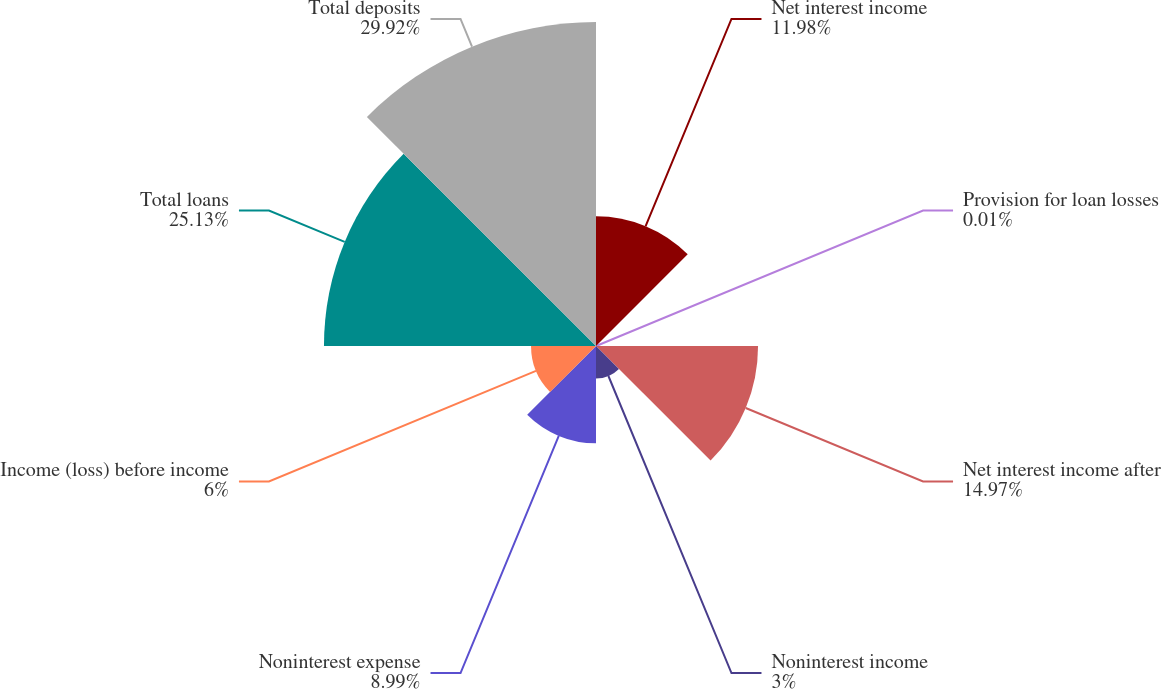Convert chart to OTSL. <chart><loc_0><loc_0><loc_500><loc_500><pie_chart><fcel>Net interest income<fcel>Provision for loan losses<fcel>Net interest income after<fcel>Noninterest income<fcel>Noninterest expense<fcel>Income (loss) before income<fcel>Total loans<fcel>Total deposits<nl><fcel>11.98%<fcel>0.01%<fcel>14.97%<fcel>3.0%<fcel>8.99%<fcel>6.0%<fcel>25.13%<fcel>29.93%<nl></chart> 